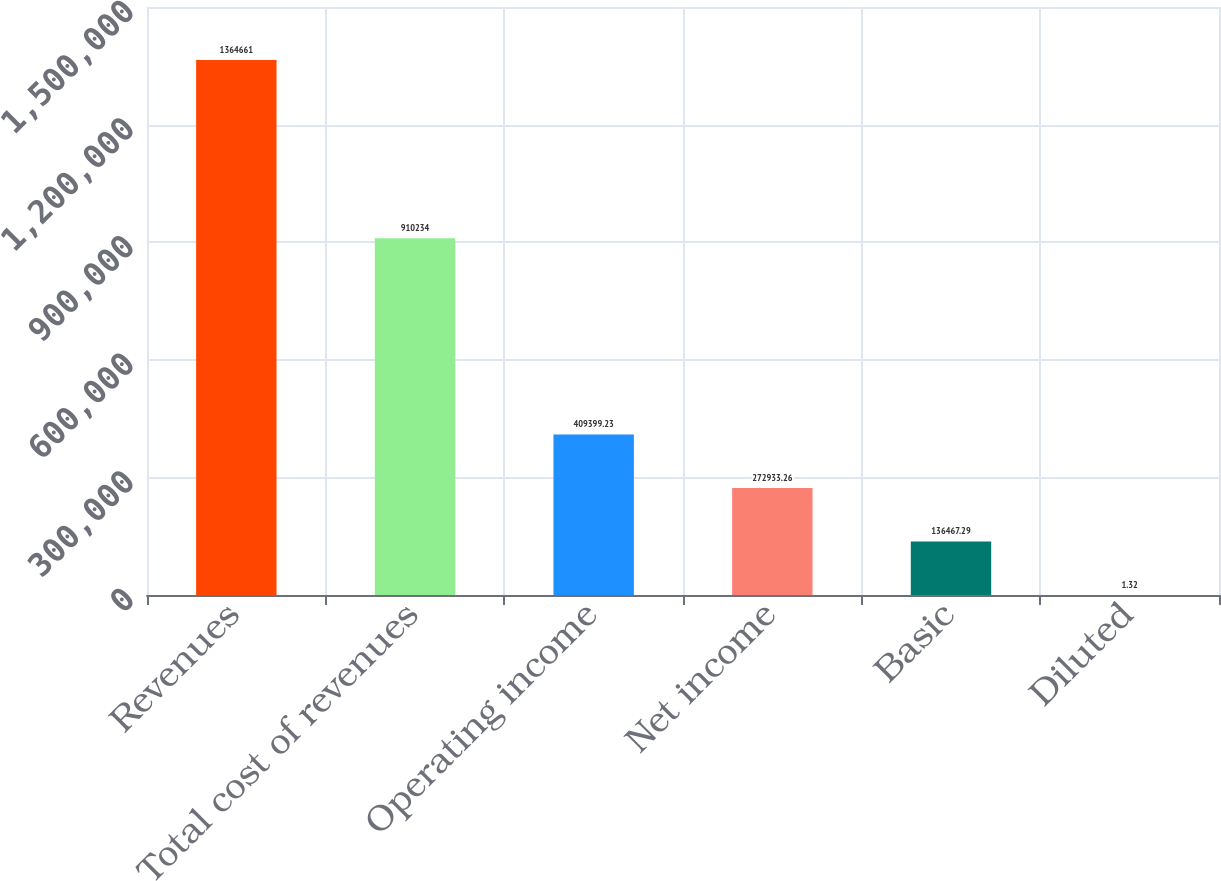<chart> <loc_0><loc_0><loc_500><loc_500><bar_chart><fcel>Revenues<fcel>Total cost of revenues<fcel>Operating income<fcel>Net income<fcel>Basic<fcel>Diluted<nl><fcel>1.36466e+06<fcel>910234<fcel>409399<fcel>272933<fcel>136467<fcel>1.32<nl></chart> 